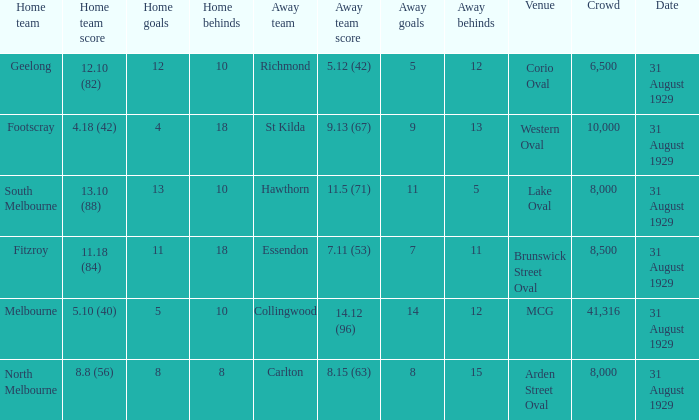What is the largest crowd when the away team is Hawthorn? 8000.0. 